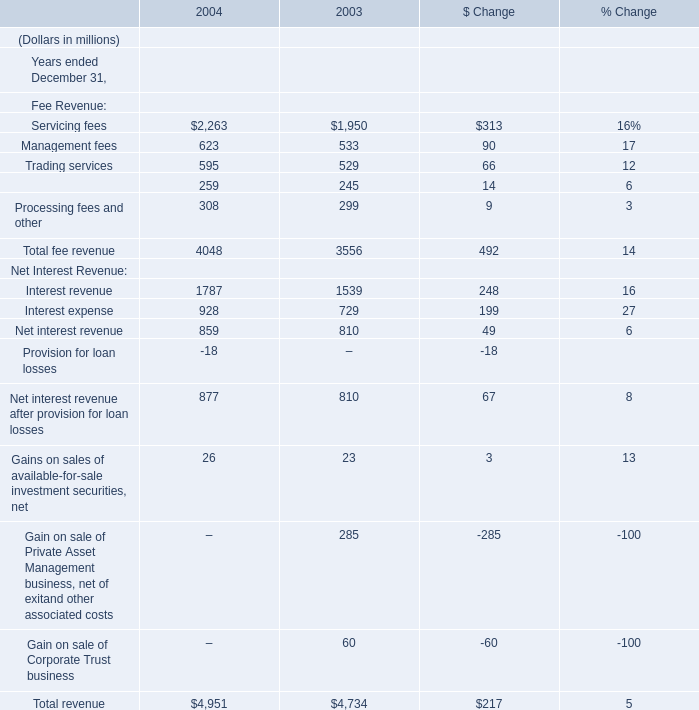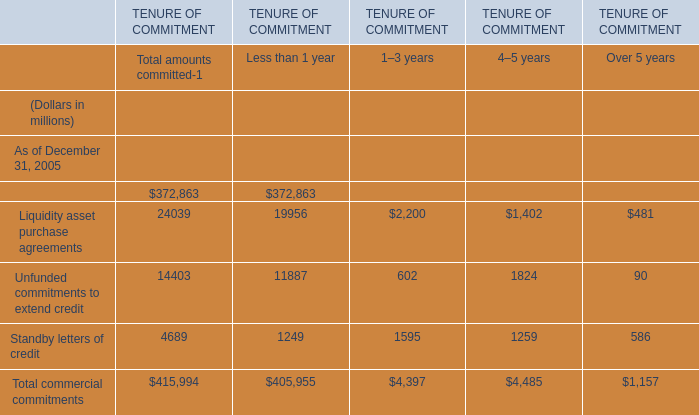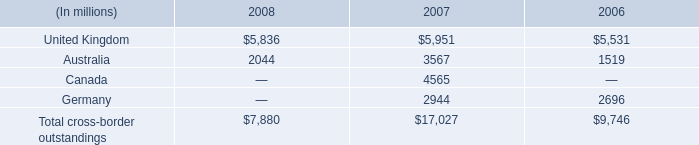what are the consolidated total assets as of december 31 , 2007? 
Computations: (17027 / 12%)
Answer: 141891.66667. 